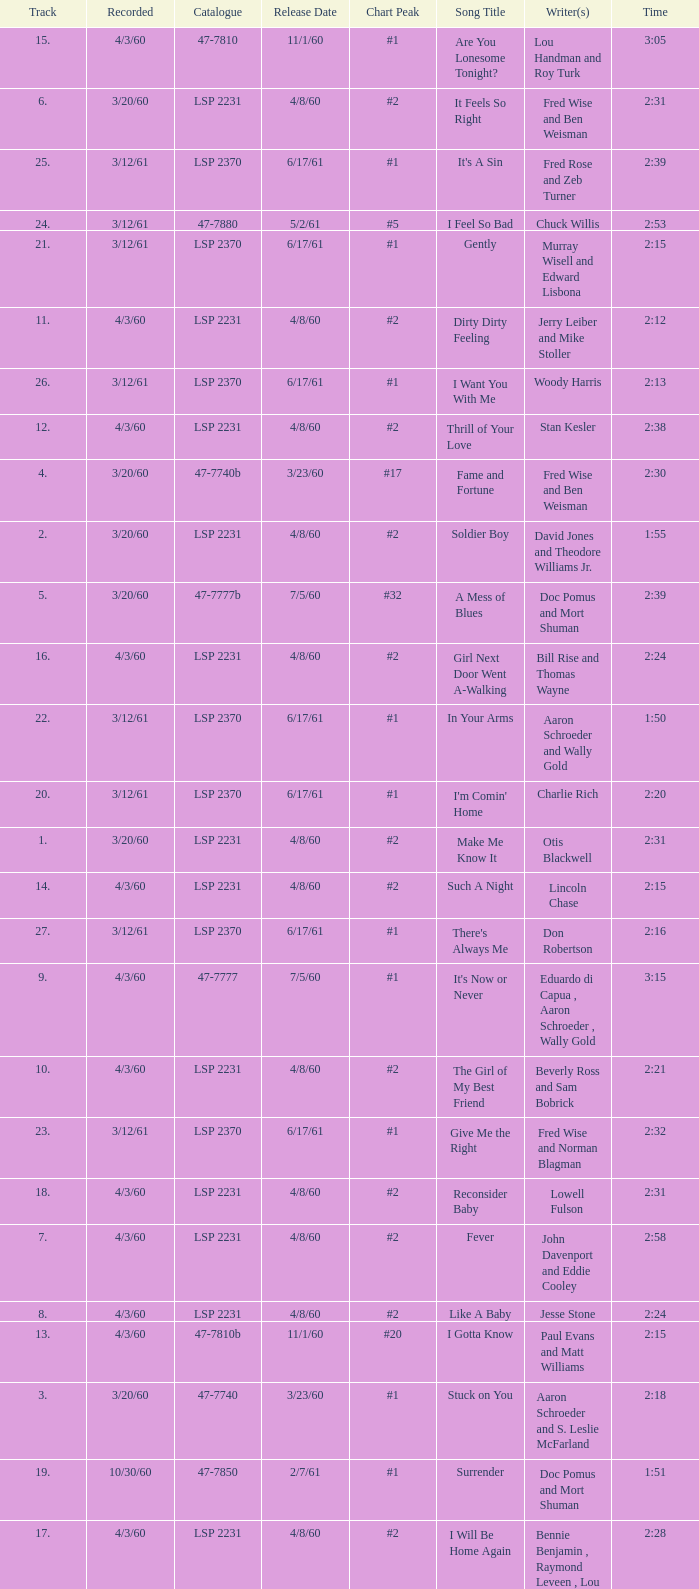What is the time of songs that have the writer Aaron Schroeder and Wally Gold? 1:50. 